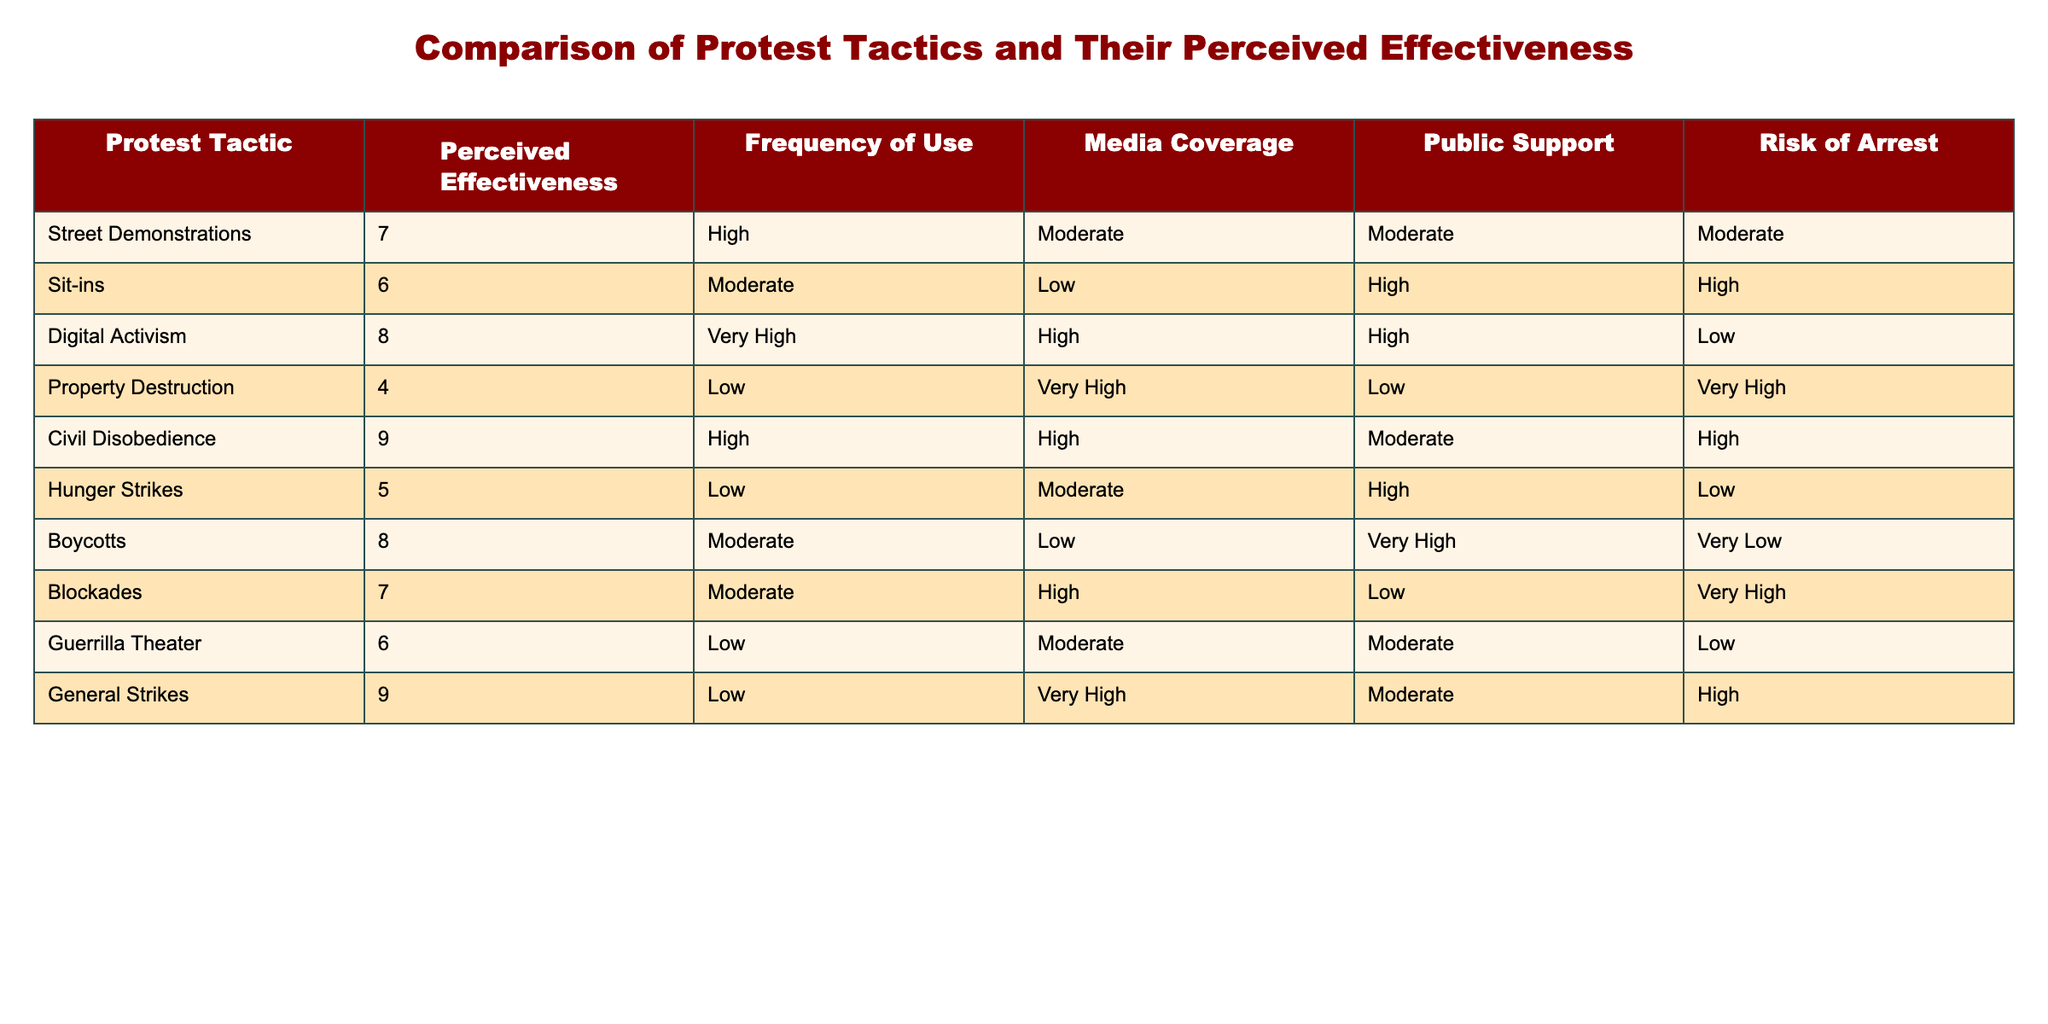What is the perceived effectiveness rating for Civil Disobedience? The table lists the perceived effectiveness rating for each protest tactic. Civil Disobedience has a rating of 9.
Answer: 9 How many protest tactics have a perceived effectiveness rating of 7 or higher? The tactics with ratings of 7 or higher are Street Demonstrations (7), Digital Activism (8), Civil Disobedience (9), and General Strikes (9). This counts as 4 tactics.
Answer: 4 Is Digital Activism considered to have a high risk of arrest? The table indicates that Digital Activism has a low risk of arrest.
Answer: No What is the average perceived effectiveness of tactics that involve low media coverage? The tactics with low media coverage are Sit-ins (6), Property Destruction (4), Hunger Strikes (5), and Boycotts (8). Their ratings are summed up (6 + 4 + 5 + 8 = 23) and then divided by 4 for the average, which equals 5.75.
Answer: 5.75 Which protest tactic has the highest perceived effectiveness and what is its frequency of use? Civil Disobedience has the highest perceived effectiveness rating of 9 and it has a high frequency of use according to the table.
Answer: Civil Disobedience, High Does the frequency of use for Boycotts exceed the frequency of use for Property Destruction? Boycotts have a moderate frequency of use, while Property Destruction has a low frequency. Since moderate implies a higher level than low, the statement is true.
Answer: Yes How many tactics have a risk of arrest categorized as "Very High"? The tactics with a "Very High" risk of arrest are Property Destruction (Very High), Blockades (Very High), and General Strikes (High). Only 2 have a "Very High" designation.
Answer: 2 What is the difference in perceived effectiveness between Street Demonstrations and Guerrilla Theater? Street Demonstrations have a score of 7 and Guerrilla Theater has a score of 6. The difference is calculated as 7 - 6 which equals 1.
Answer: 1 Which protest tactic has the most public support, and what is its perceived effectiveness? Boycotts have the most public support, rated as "Very High," and their perceived effectiveness is 8.
Answer: Boycotts, 8 Is there any protest tactic that combines high perceived effectiveness with very high frequency of use? Civil Disobedience has a perceived effectiveness of 9 and it is categorized under high frequency of use.
Answer: Yes Calculate the average risk of arrest across all protest tactics listed in the table. The risk values corresponding to each tactic are categorized as: Moderate (3), High (4), Low (2), Very Low (1). We have: 3 (Street Demonstrations) + 4 (Sit-ins) + 2 (Digital Activism) + 4 (Property Destruction) + 4 (Civil Disobedience) + 2 (Hunger Strikes) + 1 (Boycotts) + 4 (Blockades) + 2 (Guerrilla Theater) + 4 (General Strikes) = 26. The average is 26/10 = 2.6.
Answer: 2.6 